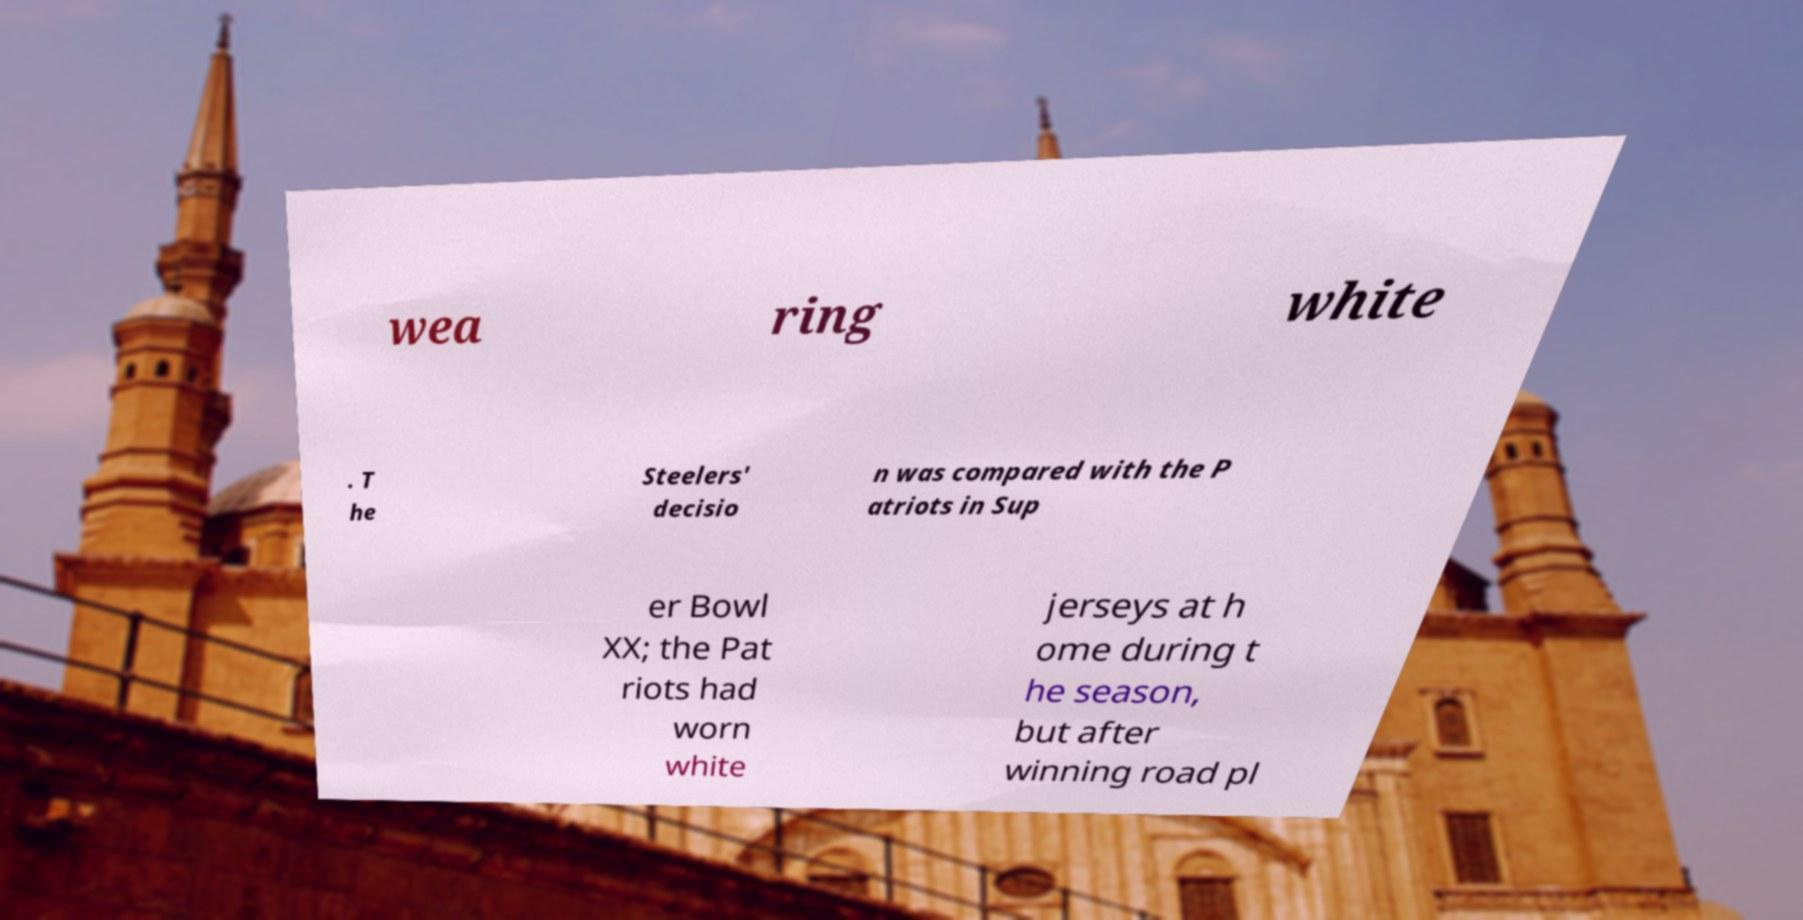What messages or text are displayed in this image? I need them in a readable, typed format. wea ring white . T he Steelers' decisio n was compared with the P atriots in Sup er Bowl XX; the Pat riots had worn white jerseys at h ome during t he season, but after winning road pl 